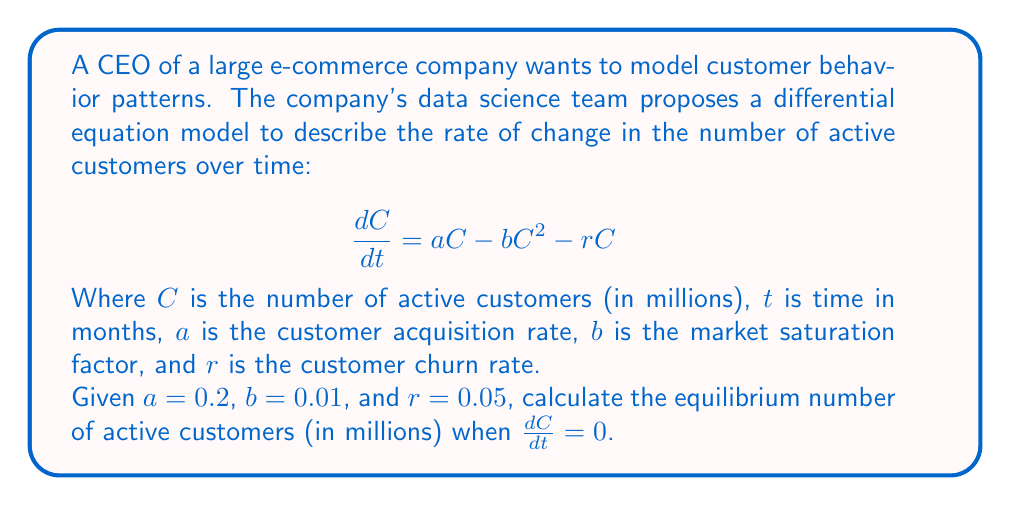Give your solution to this math problem. To find the equilibrium number of active customers, we need to solve the equation when $\frac{dC}{dt} = 0$. This represents the point at which the number of active customers is not changing over time.

1. Set the differential equation equal to zero:
   $$\frac{dC}{dt} = aC - bC^2 - rC = 0$$

2. Substitute the given values:
   $$0.2C - 0.01C^2 - 0.05C = 0$$

3. Rearrange the equation:
   $$-0.01C^2 + 0.15C = 0$$

4. Factor out C:
   $$C(-0.01C + 0.15) = 0$$

5. Solve for C:
   $C = 0$ or $-0.01C + 0.15 = 0$

6. For the non-zero solution:
   $$-0.01C = -0.15$$
   $$C = \frac{0.15}{0.01} = 15$$

Therefore, the equilibrium number of active customers is 15 million.
Answer: 15 million customers 